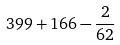<formula> <loc_0><loc_0><loc_500><loc_500>3 9 9 + 1 6 6 - \frac { 2 } { 6 2 }</formula> 